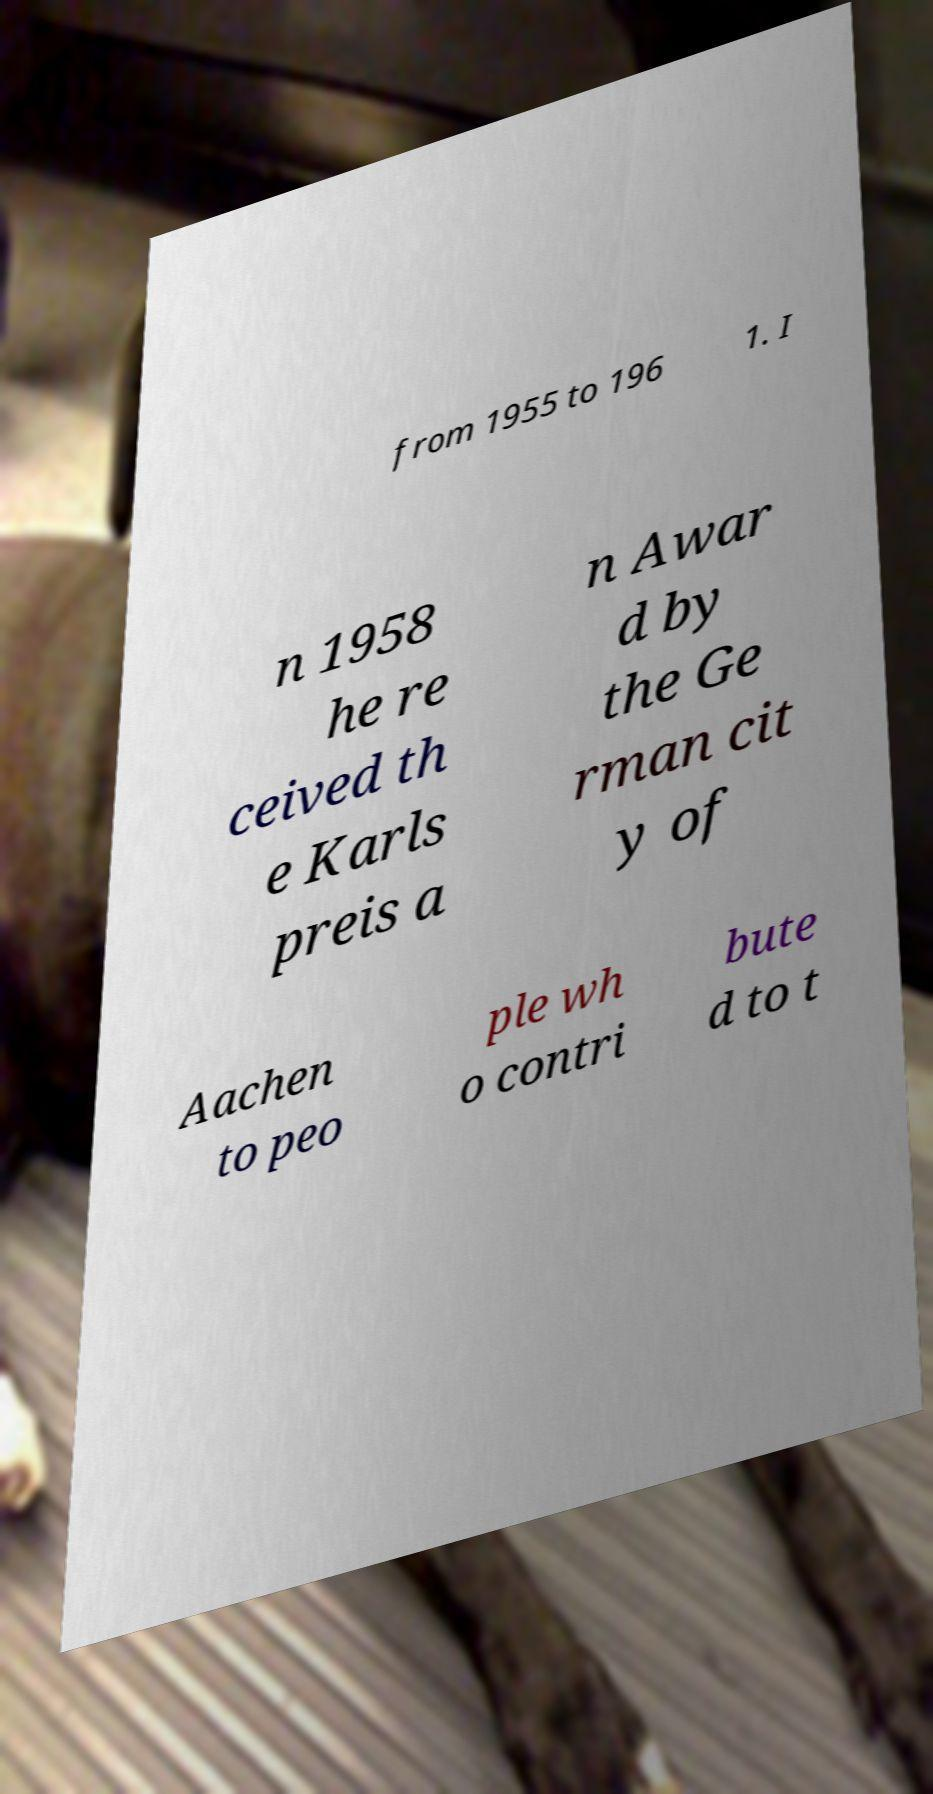Can you accurately transcribe the text from the provided image for me? from 1955 to 196 1. I n 1958 he re ceived th e Karls preis a n Awar d by the Ge rman cit y of Aachen to peo ple wh o contri bute d to t 